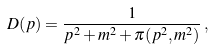Convert formula to latex. <formula><loc_0><loc_0><loc_500><loc_500>D ( p ) = \frac { 1 } { p ^ { 2 } + m ^ { 2 } + \pi ( p ^ { 2 } , m ^ { 2 } ) } \, ,</formula> 